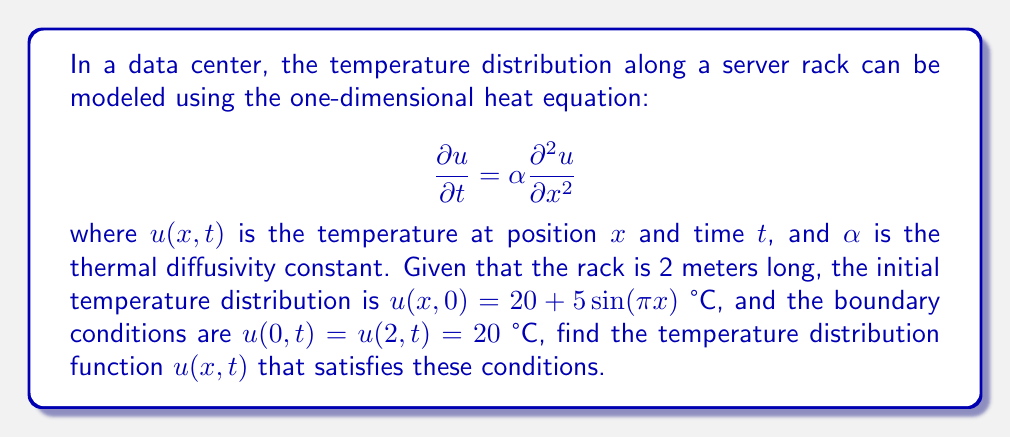Provide a solution to this math problem. To solve this problem, we'll use the method of separation of variables:

1) Assume the solution has the form $u(x,t) = X(x)T(t)$.

2) Substituting this into the heat equation:

   $$X(x)T'(t) = \alpha X''(x)T(t)$$

3) Separating variables:

   $$\frac{T'(t)}{T(t)} = \alpha \frac{X''(x)}{X(x)} = -\lambda$$

   where $-\lambda$ is a separation constant.

4) This gives us two ODEs:
   
   $$T'(t) + \lambda \alpha T(t) = 0$$
   $$X''(x) + \lambda X(x) = 0$$

5) The boundary conditions $u(0,t) = u(2,t) = 20$ imply $X(0) = X(2) = 0$.

6) The general solution for $X(x)$ that satisfies these boundary conditions is:

   $$X(x) = \sin(\frac{n\pi x}{2}), \quad n = 1,2,3,...$$

   This gives $\lambda = (\frac{n\pi}{2})^2$.

7) The solution for $T(t)$ is:

   $$T(t) = e^{-\alpha (\frac{n\pi}{2})^2 t}$$

8) The general solution is:

   $$u(x,t) = 20 + \sum_{n=1}^{\infty} b_n \sin(\frac{n\pi x}{2}) e^{-\alpha (\frac{n\pi}{2})^2 t}$$

9) To find $b_n$, we use the initial condition:

   $$20 + 5\sin(\pi x) = 20 + \sum_{n=1}^{\infty} b_n \sin(\frac{n\pi x}{2})$$

10) This implies $b_1 = 5$ and $b_n = 0$ for $n \neq 1$.

Therefore, the final solution is:

$$u(x,t) = 20 + 5\sin(\frac{\pi x}{2}) e^{-\alpha (\frac{\pi}{2})^2 t}$$
Answer: $$u(x,t) = 20 + 5\sin(\frac{\pi x}{2}) e^{-\alpha (\frac{\pi}{2})^2 t}$$ 